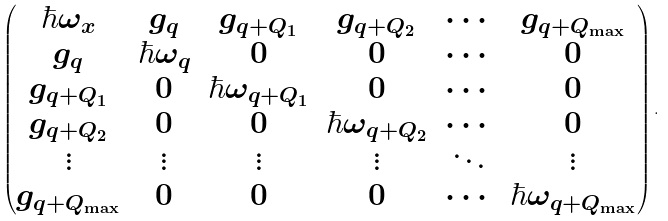<formula> <loc_0><loc_0><loc_500><loc_500>\begin{pmatrix} \hbar { \omega } _ { x } & g _ { q } & g _ { q + Q _ { 1 } } & g _ { q + Q _ { 2 } } & \cdots & g _ { q + Q _ { \max } } \\ g _ { q } & \hbar { \omega } _ { q } & 0 & 0 & \cdots & 0 \\ g _ { q + Q _ { 1 } } & 0 & \hbar { \omega } _ { q + Q _ { 1 } } & 0 & \cdots & 0 \\ g _ { q + Q _ { 2 } } & 0 & 0 & \hbar { \omega } _ { q + Q _ { 2 } } & \cdots & 0 \\ \vdots & \vdots & \vdots & \vdots & \ddots & \vdots \\ g _ { q + Q _ { \max } } & 0 & 0 & 0 & \cdots & \hbar { \omega } _ { q + Q _ { \max } } \end{pmatrix} .</formula> 